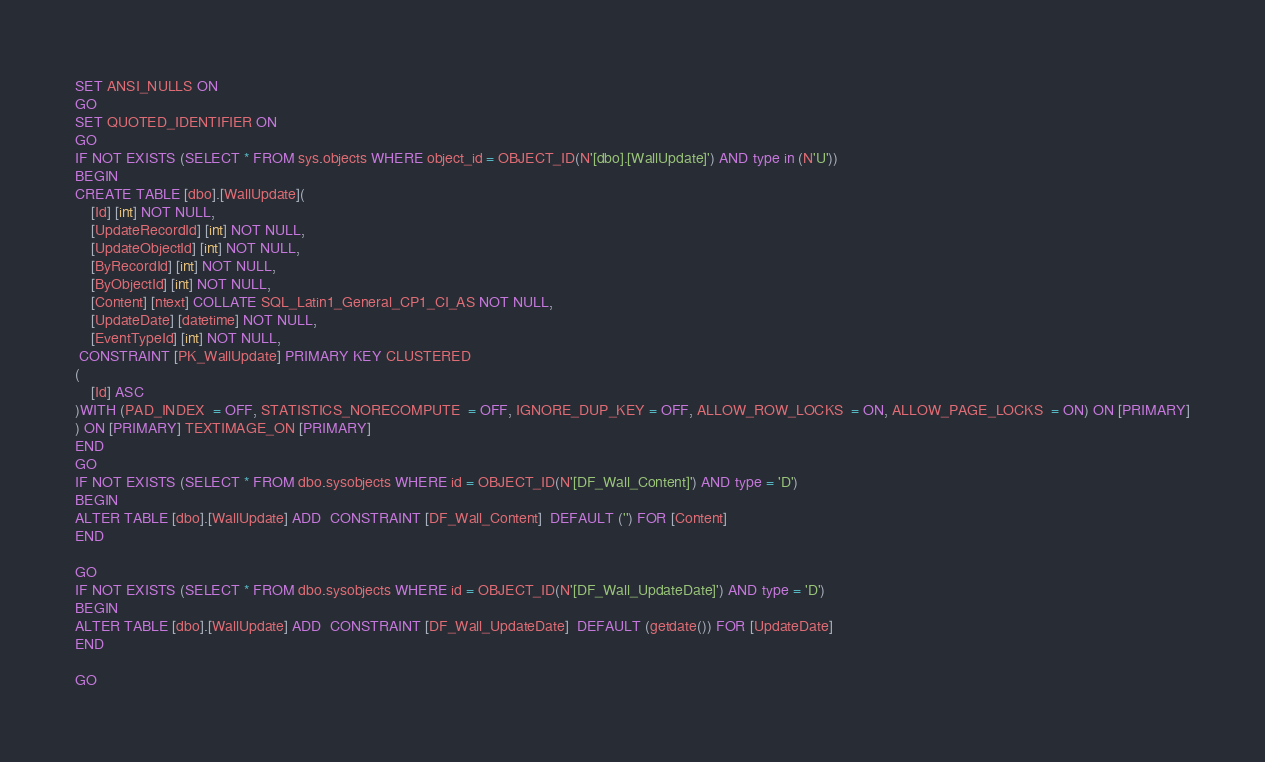Convert code to text. <code><loc_0><loc_0><loc_500><loc_500><_SQL_>SET ANSI_NULLS ON
GO
SET QUOTED_IDENTIFIER ON
GO
IF NOT EXISTS (SELECT * FROM sys.objects WHERE object_id = OBJECT_ID(N'[dbo].[WallUpdate]') AND type in (N'U'))
BEGIN
CREATE TABLE [dbo].[WallUpdate](
	[Id] [int] NOT NULL,
	[UpdateRecordId] [int] NOT NULL,
	[UpdateObjectId] [int] NOT NULL,
	[ByRecordId] [int] NOT NULL,
	[ByObjectId] [int] NOT NULL,
	[Content] [ntext] COLLATE SQL_Latin1_General_CP1_CI_AS NOT NULL,
	[UpdateDate] [datetime] NOT NULL,
	[EventTypeId] [int] NOT NULL,
 CONSTRAINT [PK_WallUpdate] PRIMARY KEY CLUSTERED 
(
	[Id] ASC
)WITH (PAD_INDEX  = OFF, STATISTICS_NORECOMPUTE  = OFF, IGNORE_DUP_KEY = OFF, ALLOW_ROW_LOCKS  = ON, ALLOW_PAGE_LOCKS  = ON) ON [PRIMARY]
) ON [PRIMARY] TEXTIMAGE_ON [PRIMARY]
END
GO
IF NOT EXISTS (SELECT * FROM dbo.sysobjects WHERE id = OBJECT_ID(N'[DF_Wall_Content]') AND type = 'D')
BEGIN
ALTER TABLE [dbo].[WallUpdate] ADD  CONSTRAINT [DF_Wall_Content]  DEFAULT ('') FOR [Content]
END

GO
IF NOT EXISTS (SELECT * FROM dbo.sysobjects WHERE id = OBJECT_ID(N'[DF_Wall_UpdateDate]') AND type = 'D')
BEGIN
ALTER TABLE [dbo].[WallUpdate] ADD  CONSTRAINT [DF_Wall_UpdateDate]  DEFAULT (getdate()) FOR [UpdateDate]
END

GO</code> 